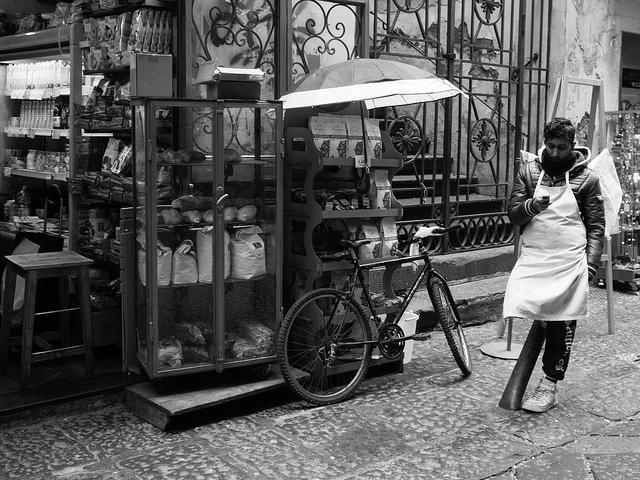How many people are in the picture?
Give a very brief answer. 1. How many horses are there?
Give a very brief answer. 0. 